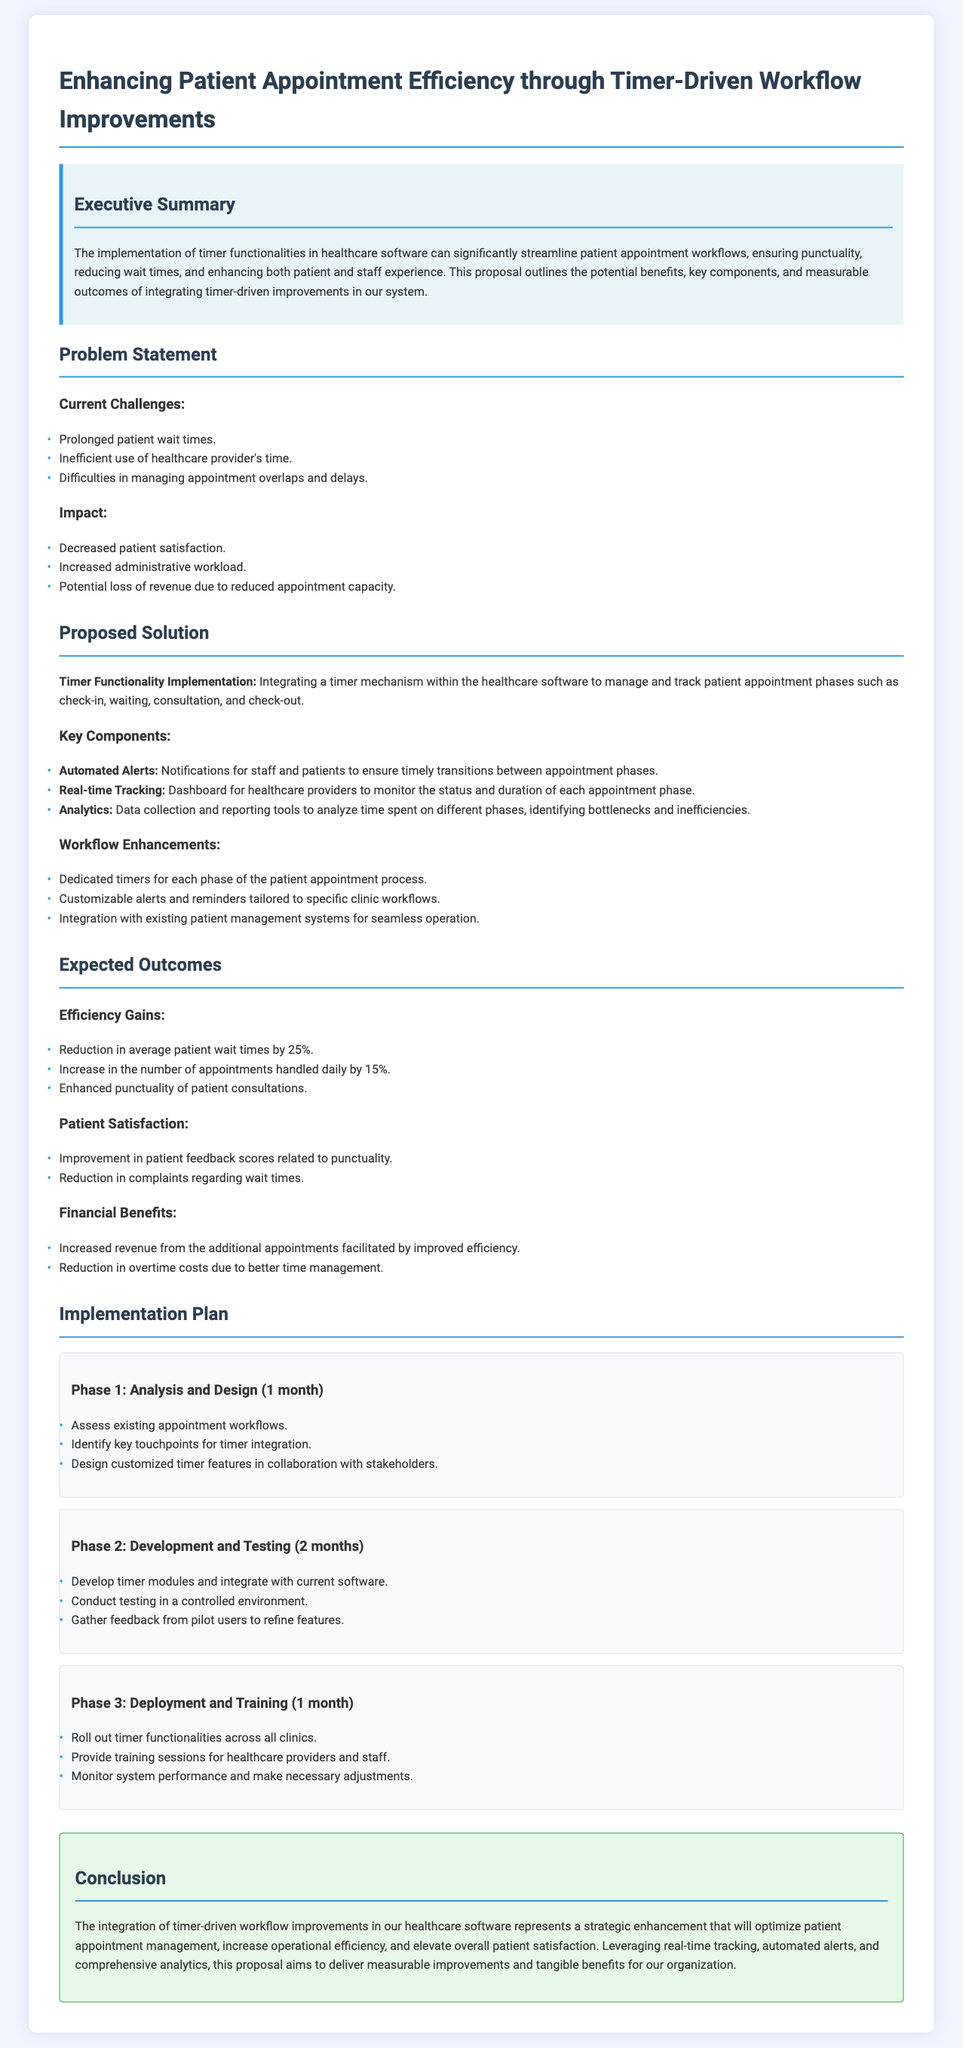what is the title of the proposal? The title is a main heading of the document which summarizes the overall theme, which is "Enhancing Patient Appointment Efficiency through Timer-Driven Workflow Improvements."
Answer: Enhancing Patient Appointment Efficiency through Timer-Driven Workflow Improvements how much can patient wait times be reduced by implementing the timer functionality? The document states that the implementation is expected to result in a reduction in average patient wait times by 25%.
Answer: 25% what are the three phases of the implementation plan? The document outlines three phases: Analysis and Design, Development and Testing, and Deployment and Training.
Answer: Analysis and Design, Development and Testing, Deployment and Training what types of alerts will be included in the proposed solution? The proposed solution mentions automated alerts for both staff and patients to ensure timely transitions between appointment phases.
Answer: Automated Alerts what is the expected increase in the number of appointments handled daily? The document mentions an expected increase in the number of appointments handled daily by 15%.
Answer: 15% what is one key component of the proposed solution? The proposed solution includes key components such as Real-time Tracking, which allows monitoring of the status and duration of each appointment phase.
Answer: Real-time Tracking what is the duration of Phase 2 in the implementation plan? Phase 2, which involves Development and Testing, has a duration of 2 months as specified in the implementation plan section.
Answer: 2 months what is the impact of prolonged patient wait times mentioned in the document? The document states that prolonged patient wait times can lead to decreased patient satisfaction among other issues.
Answer: Decreased patient satisfaction what will be monitored after deploying the timer functionalities? The document states that after deployment, the system performance will be monitored and necessary adjustments will be made.
Answer: System performance 